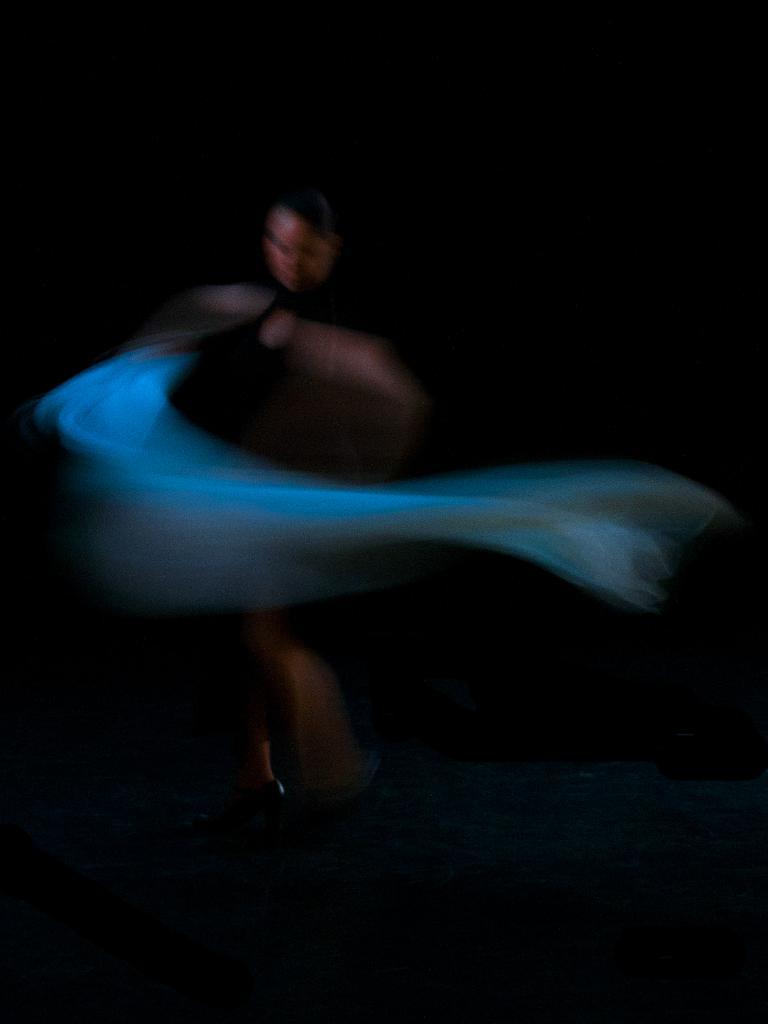Describe this image in one or two sentences. This is a blur image. In this image we can see a woman standing on the floor holding a cloth. 